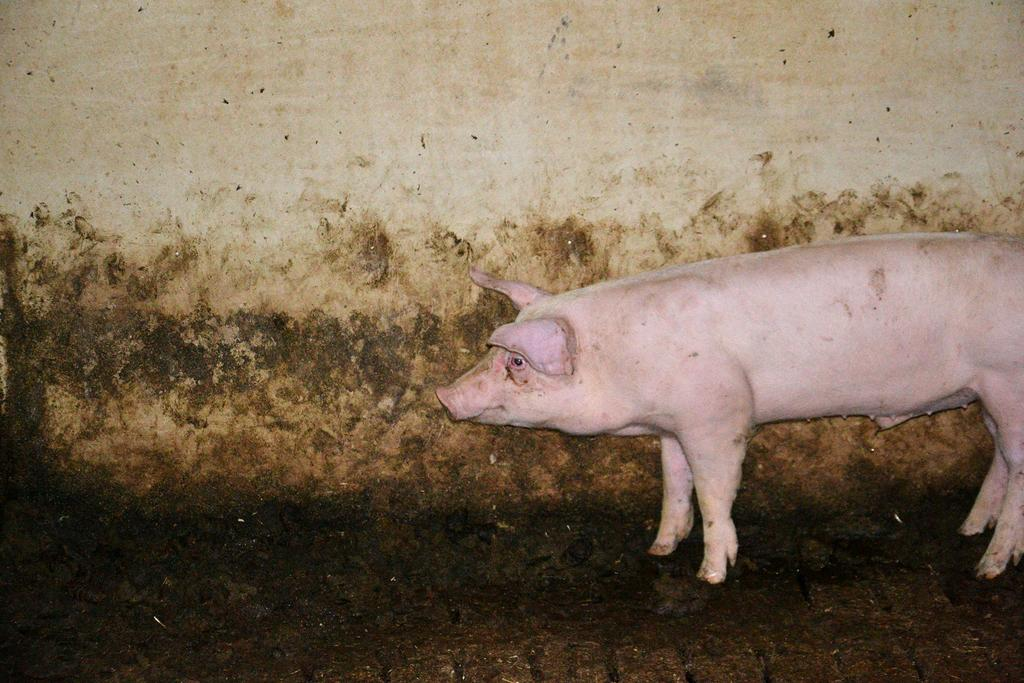What animal is present in the picture? There is a pig in the picture. What can be seen in the background of the picture? There is a wall in the background of the picture. What type of sea creature can be seen swimming near the pig in the picture? There is no sea creature present in the picture, as it features a pig and a wall. What shape is the pig in the picture? The shape of the pig cannot be determined from the picture alone, as it is a two-dimensional representation. 